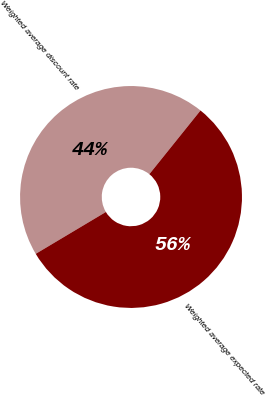Convert chart to OTSL. <chart><loc_0><loc_0><loc_500><loc_500><pie_chart><fcel>Weighted average discount rate<fcel>Weighted average expected rate<nl><fcel>44.33%<fcel>55.67%<nl></chart> 